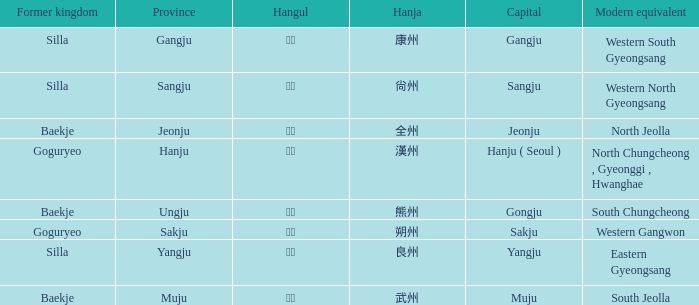What is the hangul symbol for the hanja 良州? 양주. 